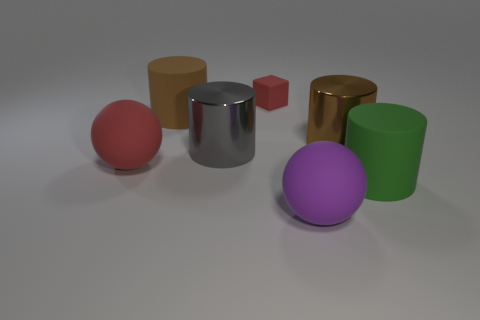There is a large ball that is the same color as the small rubber cube; what is it made of?
Make the answer very short. Rubber. Are there the same number of tiny red things that are left of the small red matte cube and brown metallic cylinders on the right side of the brown metal cylinder?
Offer a very short reply. Yes. The large cylinder that is on the left side of the purple object and on the right side of the brown rubber cylinder is what color?
Your answer should be compact. Gray. Is there any other thing that is the same size as the brown metallic object?
Your response must be concise. Yes. Is the number of large gray metal things that are in front of the large red matte thing greater than the number of cylinders behind the large brown matte thing?
Provide a short and direct response. No. There is a red rubber thing that is on the left side of the gray cylinder; is its size the same as the big brown rubber cylinder?
Give a very brief answer. Yes. How many large purple matte balls are right of the matte cylinder behind the large cylinder that is in front of the large gray shiny cylinder?
Give a very brief answer. 1. There is a cylinder that is behind the gray object and to the right of the large purple thing; what size is it?
Make the answer very short. Large. What number of other things are the same shape as the small red object?
Provide a short and direct response. 0. What number of green cylinders are on the left side of the green matte object?
Give a very brief answer. 0. 